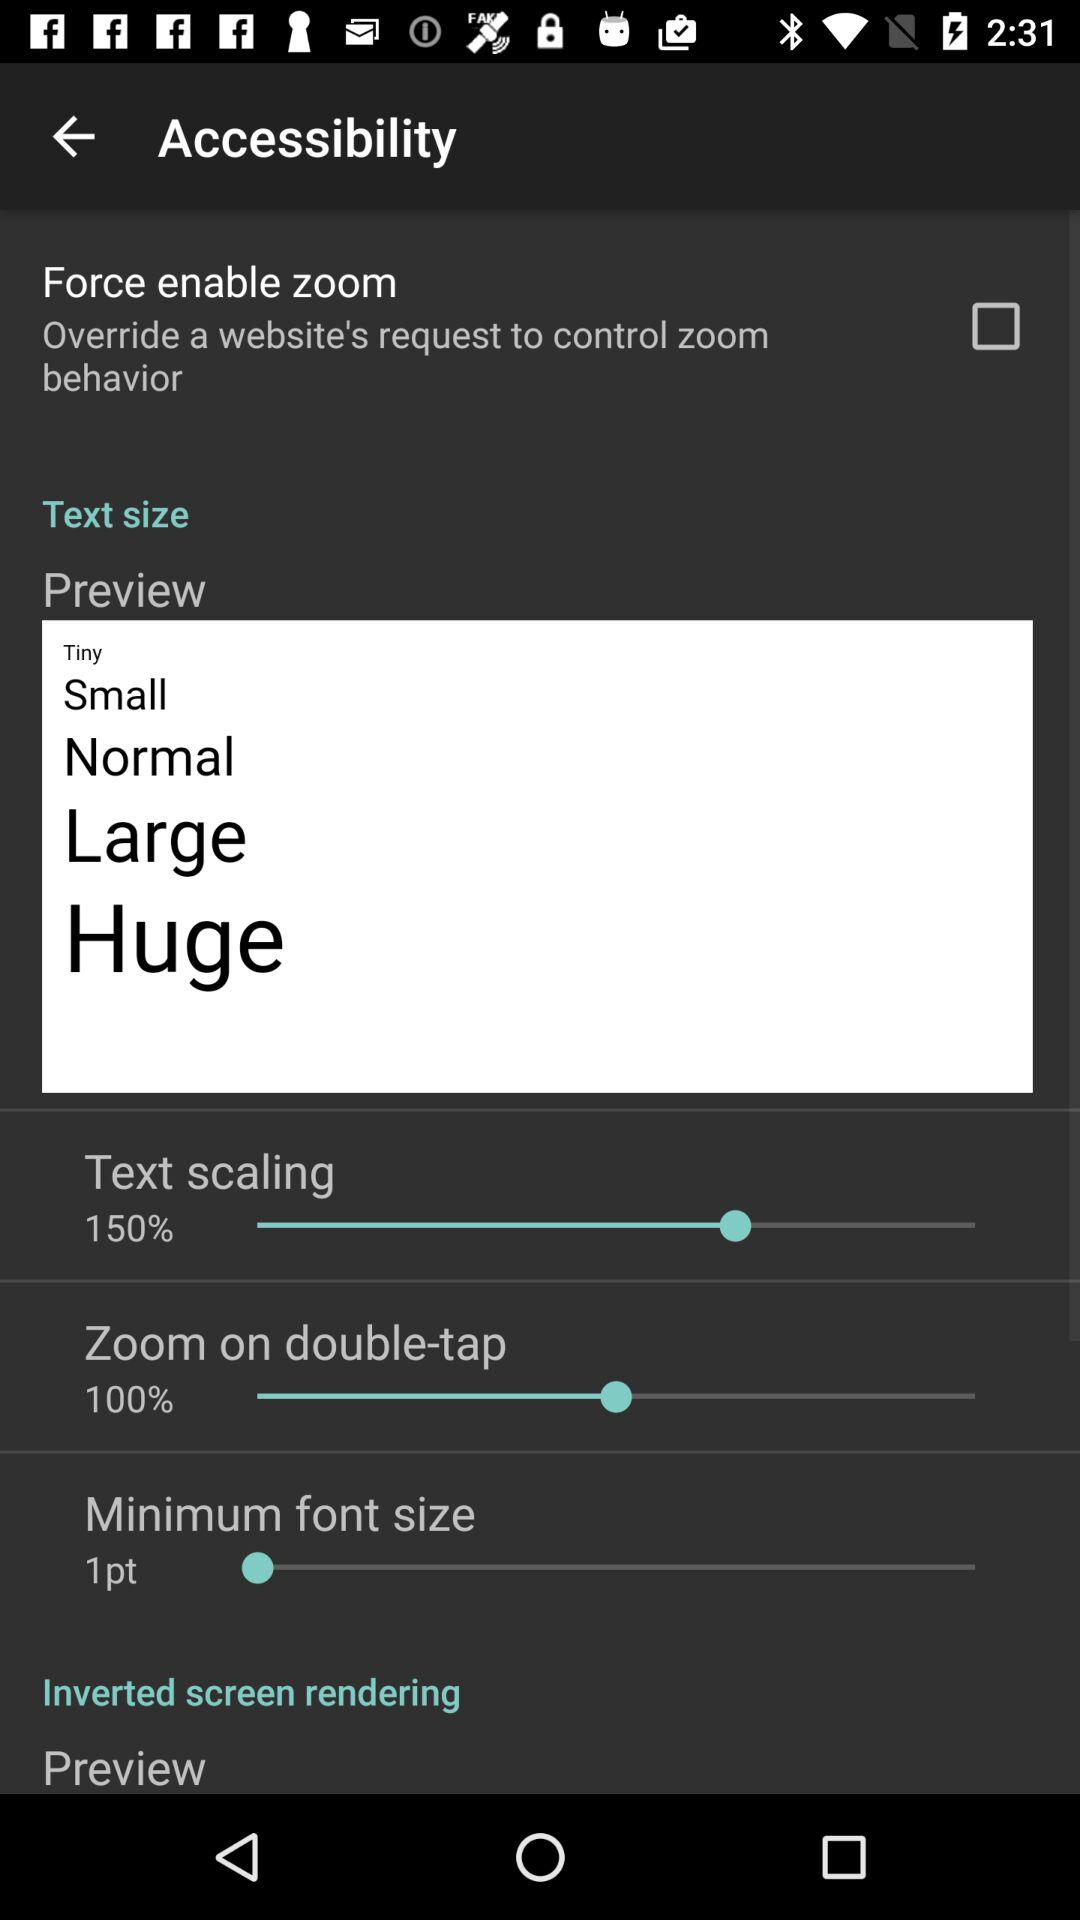What is the minimum font size? The minimum font size is 1 point. 